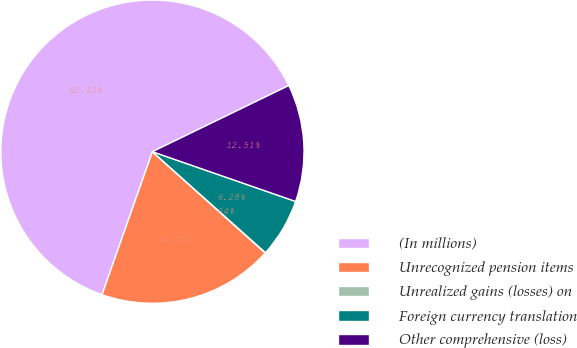Convert chart. <chart><loc_0><loc_0><loc_500><loc_500><pie_chart><fcel>(In millions)<fcel>Unrecognized pension items<fcel>Unrealized gains (losses) on<fcel>Foreign currency translation<fcel>Other comprehensive (loss)<nl><fcel>62.42%<fcel>18.75%<fcel>0.04%<fcel>6.28%<fcel>12.51%<nl></chart> 